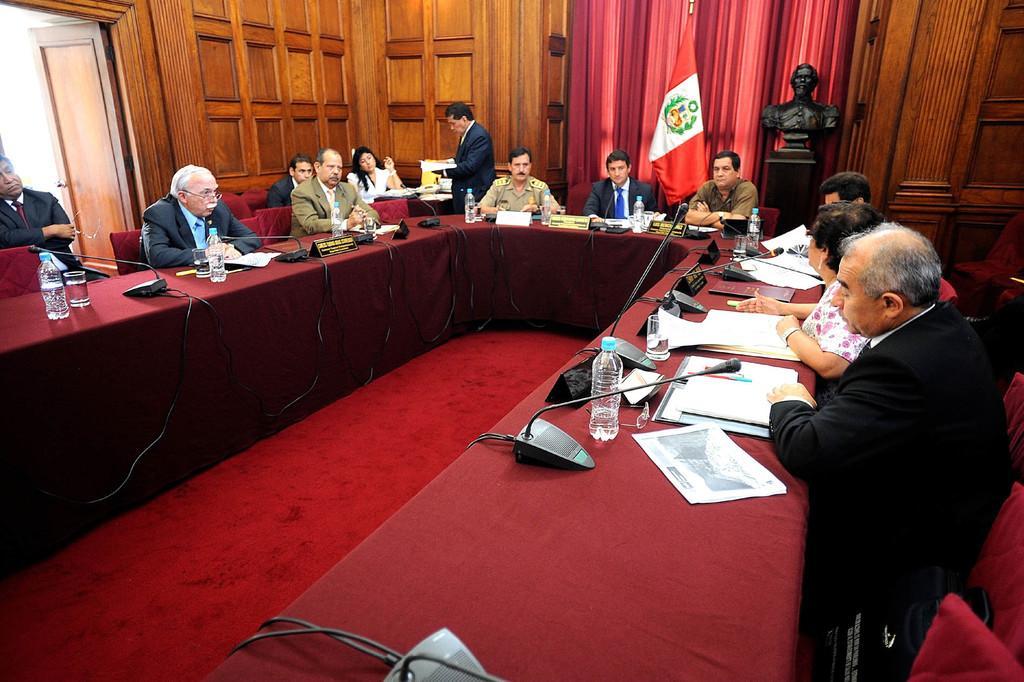In one or two sentences, can you explain what this image depicts? In the picture we can see a desk with a red colored cloth on it and on it we can see some water bottles, glasses, papers, microphones and near the desk, we can see some people are sitting in the chairs and in the background, we can see a wooden wall and a door and beside it we can see a red color curtain and beside it we can see a sculpture which is black in color. 